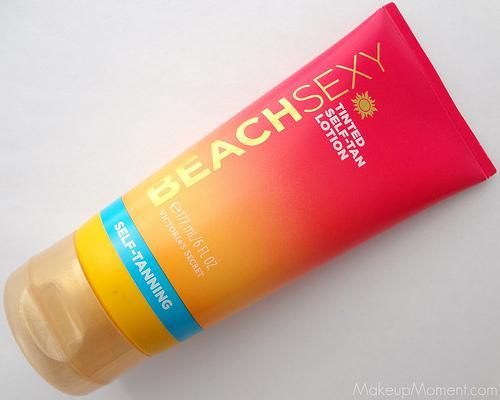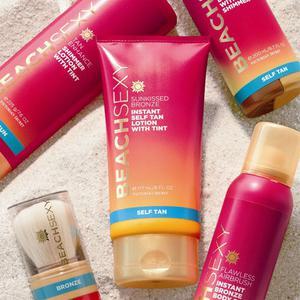The first image is the image on the left, the second image is the image on the right. Examine the images to the left and right. Is the description "There are a total of 5 brightly colored self-tanning accessories laying in the sand." accurate? Answer yes or no. Yes. The first image is the image on the left, the second image is the image on the right. Evaluate the accuracy of this statement regarding the images: "bottles of lotion are displayed on a sandy surface". Is it true? Answer yes or no. Yes. 